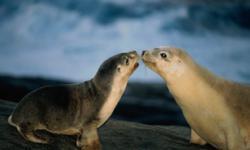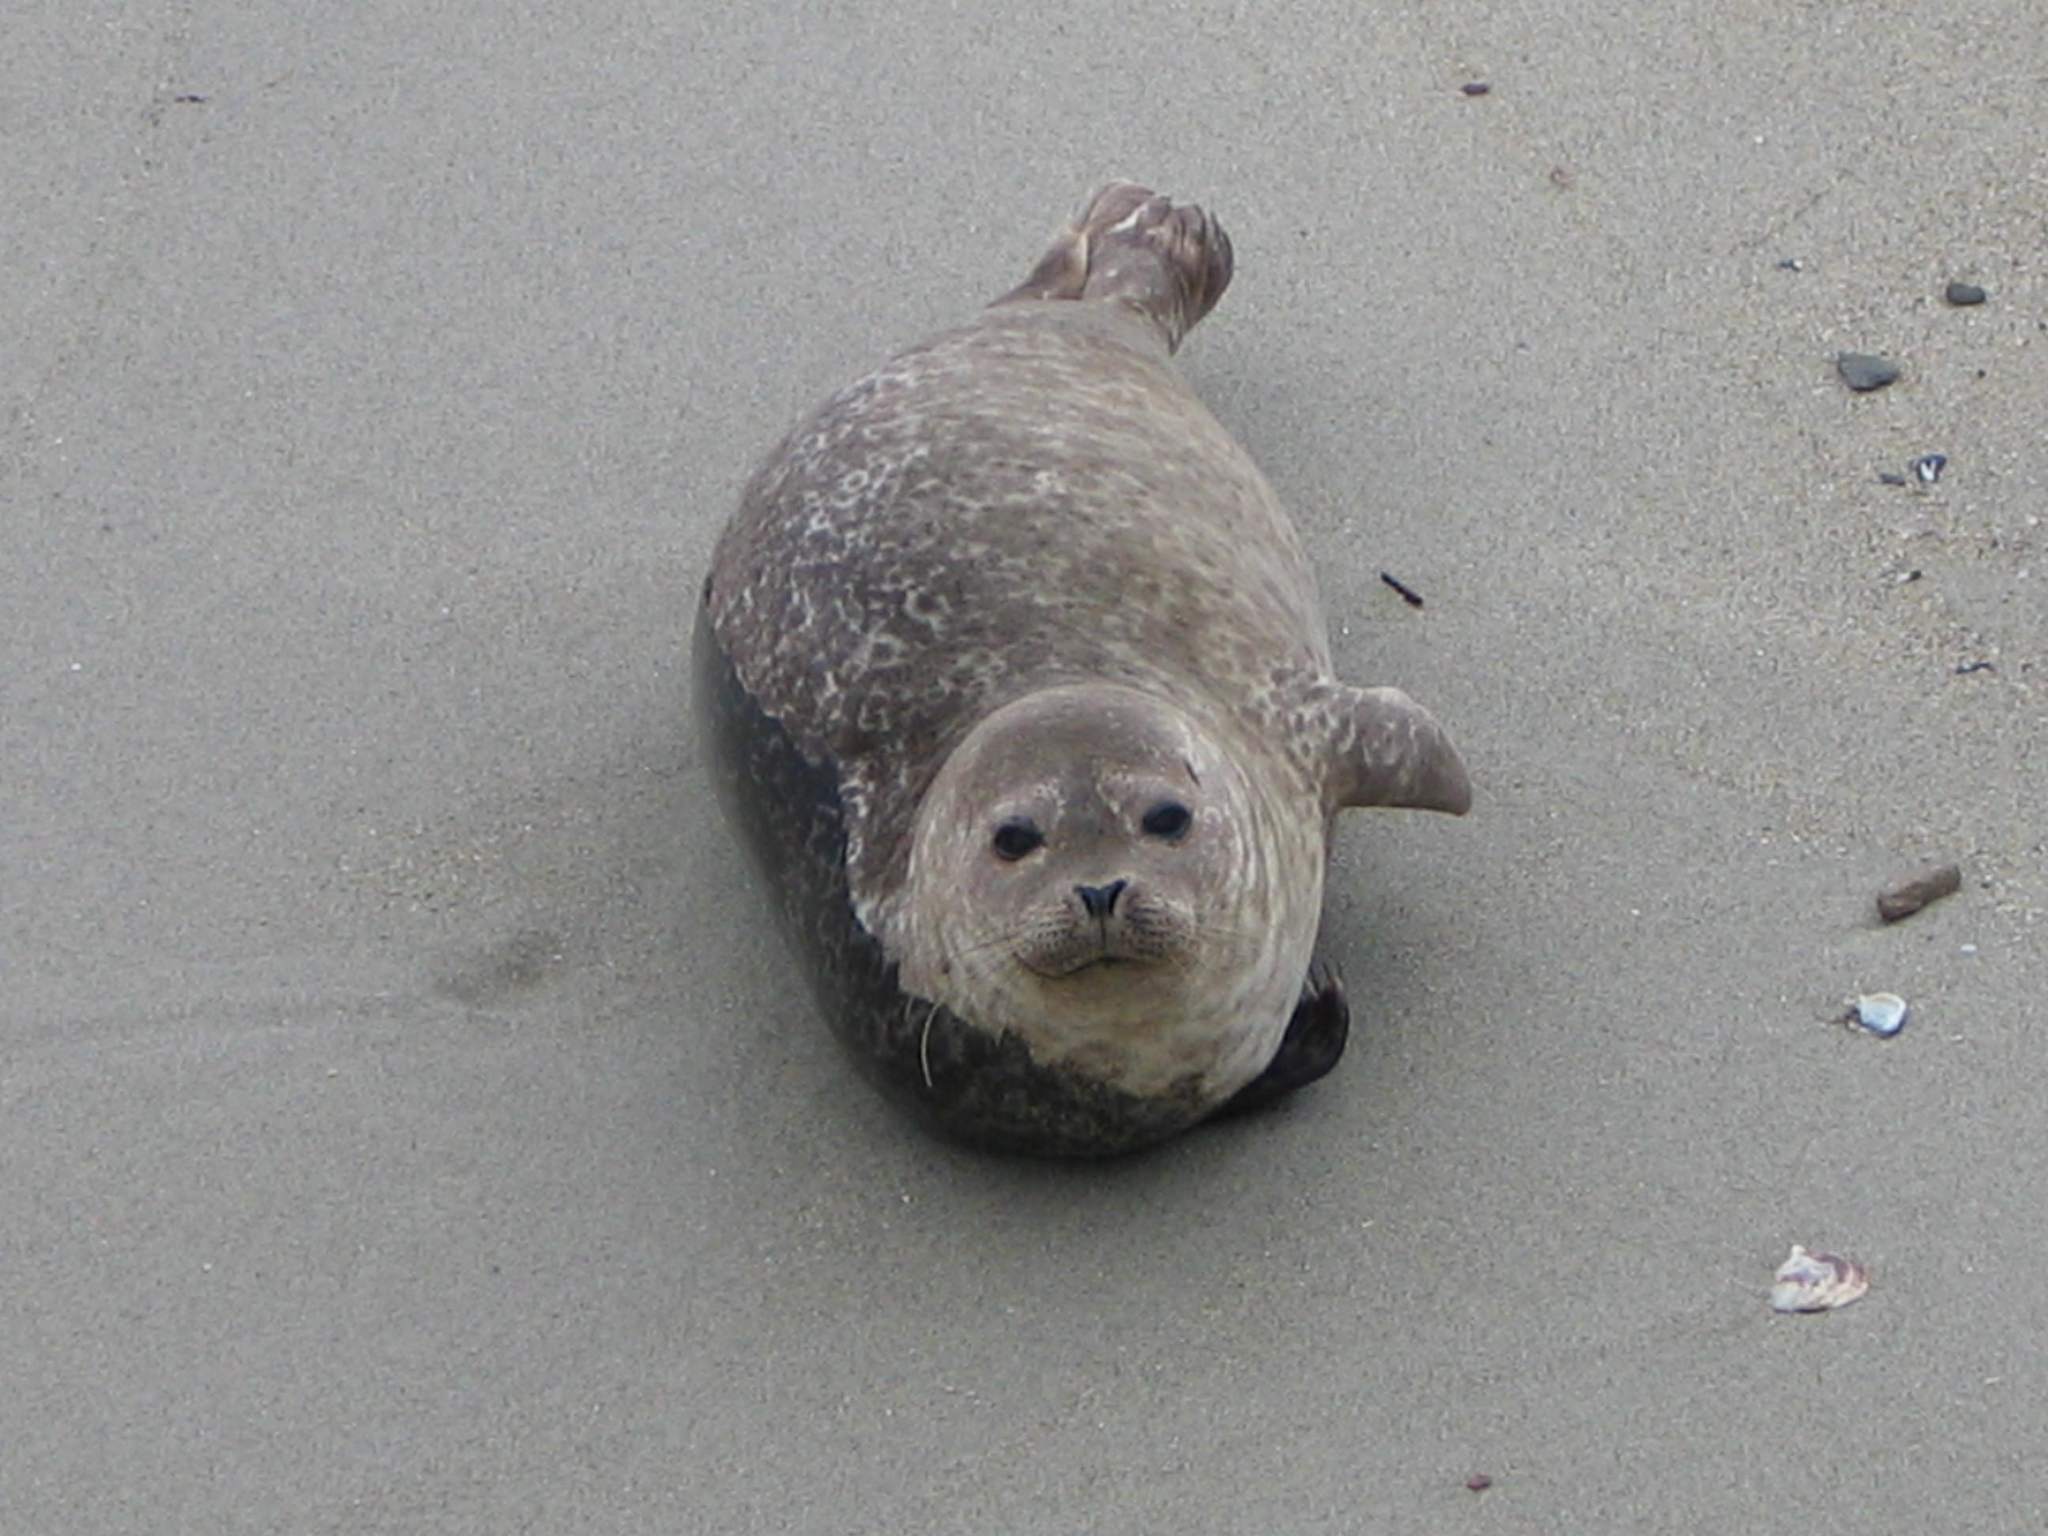The first image is the image on the left, the second image is the image on the right. Analyze the images presented: Is the assertion "One image shows a seal lying on its side on a flat, unelevated surface with its head raised and turned to the camera." valid? Answer yes or no. Yes. The first image is the image on the left, the second image is the image on the right. Given the left and right images, does the statement "In the right image there is a single seal looking at the camera." hold true? Answer yes or no. Yes. 